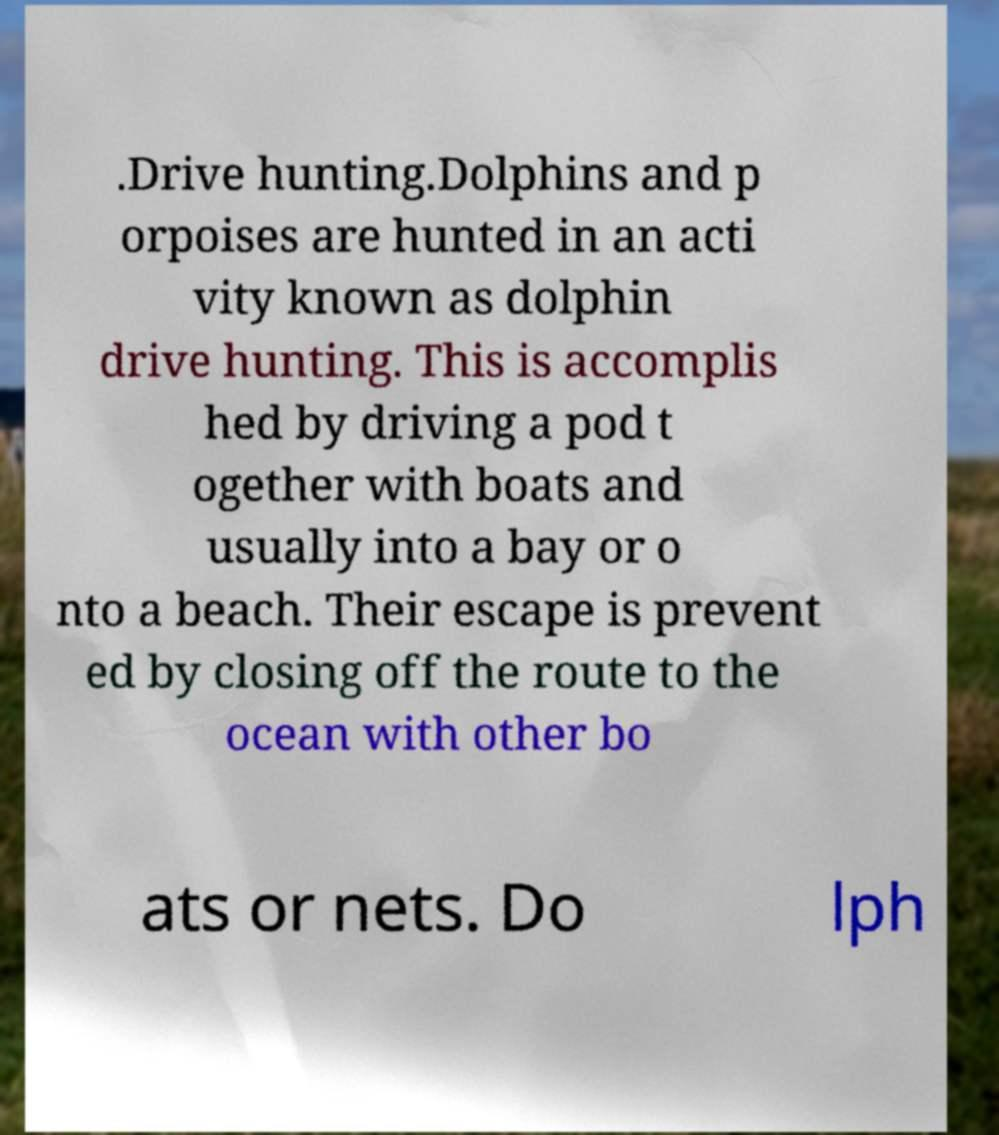Could you extract and type out the text from this image? .Drive hunting.Dolphins and p orpoises are hunted in an acti vity known as dolphin drive hunting. This is accomplis hed by driving a pod t ogether with boats and usually into a bay or o nto a beach. Their escape is prevent ed by closing off the route to the ocean with other bo ats or nets. Do lph 